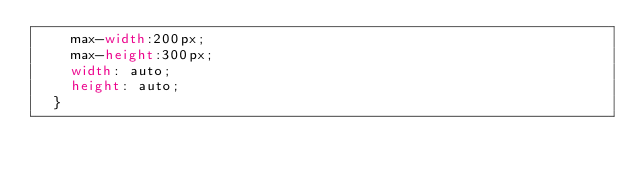<code> <loc_0><loc_0><loc_500><loc_500><_CSS_>    max-width:200px;
    max-height:300px;
    width: auto;
    height: auto;
  }</code> 